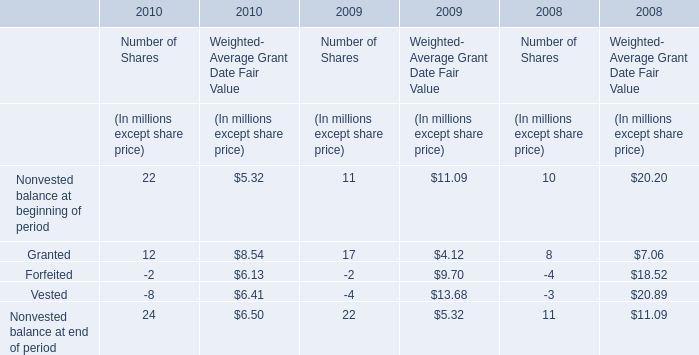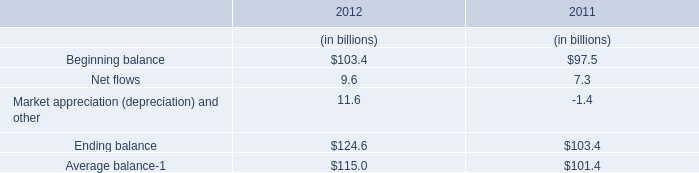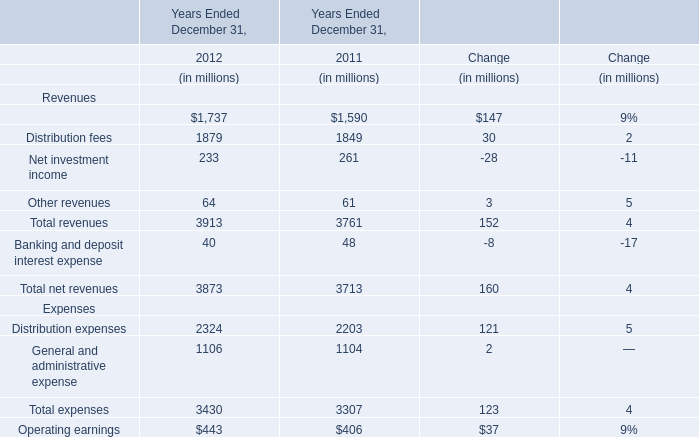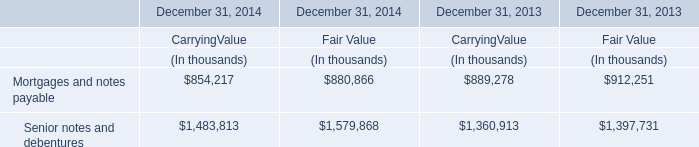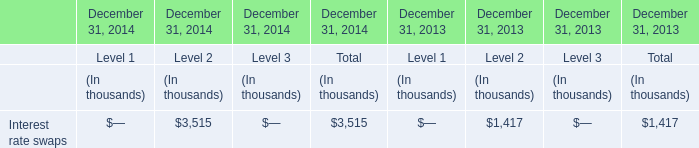What's the total amount of revenues excluding Management and financial advice fees and Distribution fees in 2012? (in million) 
Computations: (233 + 64)
Answer: 297.0. 